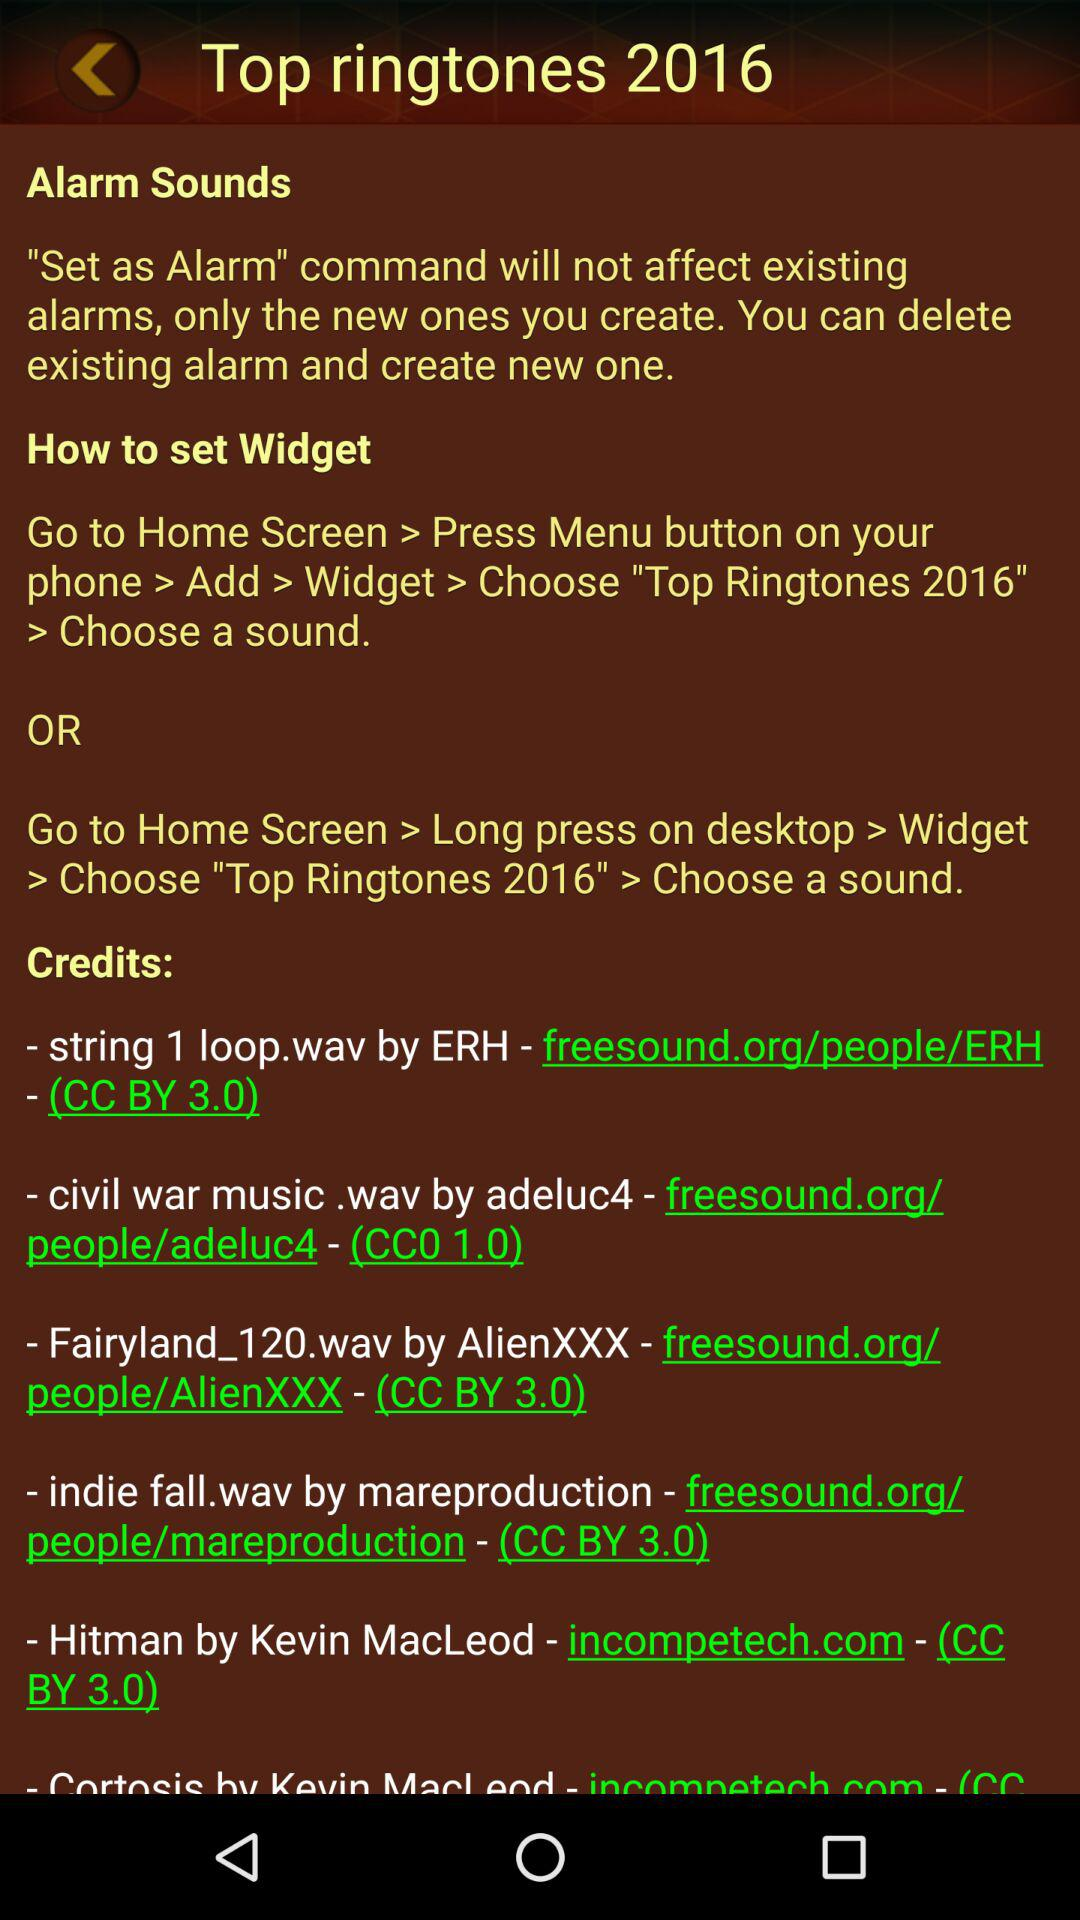What are the steps for setting the alarm sounds? The steps for setting the alarm sounds are "Go to Home Screen > Press Menu button on your phone > Add > Widget > Choose "Top Ringtones 2016" > Choose a sound" or "Go to Home Screen > Long press on desktop > Widget > Choose "Top Ringtones 2016" > Choose a sound". 